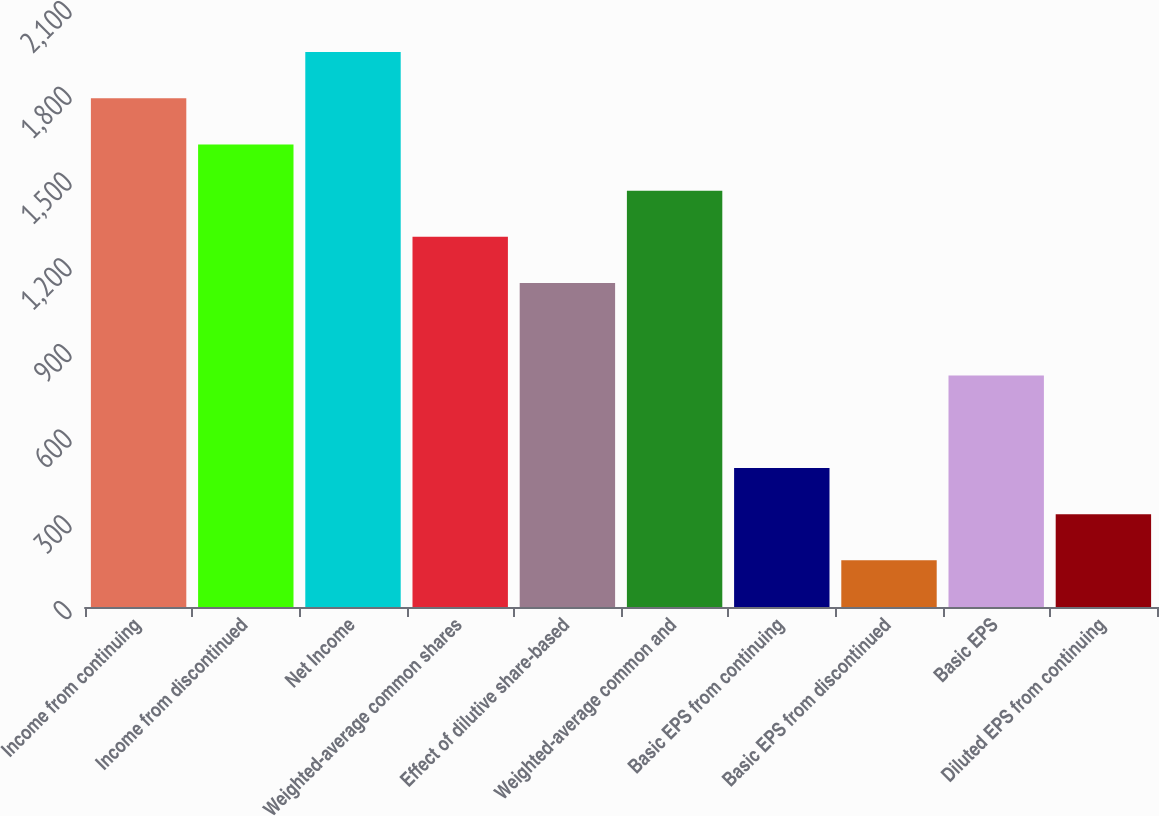<chart> <loc_0><loc_0><loc_500><loc_500><bar_chart><fcel>Income from continuing<fcel>Income from discontinued<fcel>Net Income<fcel>Weighted-average common shares<fcel>Effect of dilutive share-based<fcel>Weighted-average common and<fcel>Basic EPS from continuing<fcel>Basic EPS from discontinued<fcel>Basic EPS<fcel>Diluted EPS from continuing<nl><fcel>1780.7<fcel>1618.96<fcel>1942.44<fcel>1295.48<fcel>1133.74<fcel>1457.22<fcel>486.78<fcel>163.3<fcel>810.26<fcel>325.04<nl></chart> 